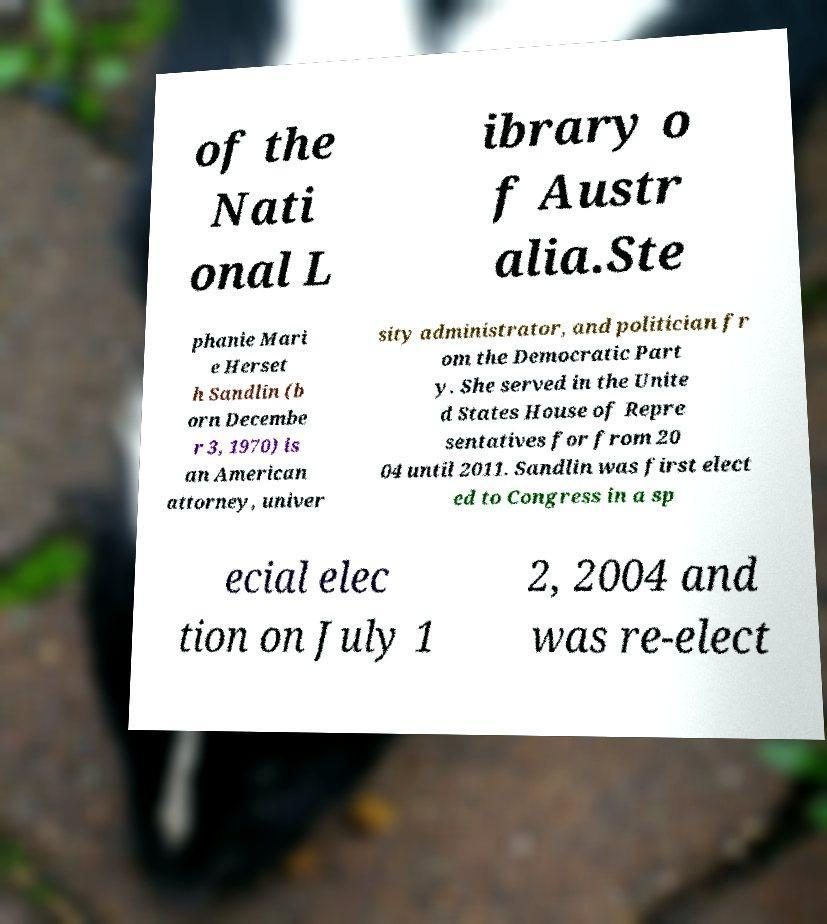Could you extract and type out the text from this image? of the Nati onal L ibrary o f Austr alia.Ste phanie Mari e Herset h Sandlin (b orn Decembe r 3, 1970) is an American attorney, univer sity administrator, and politician fr om the Democratic Part y. She served in the Unite d States House of Repre sentatives for from 20 04 until 2011. Sandlin was first elect ed to Congress in a sp ecial elec tion on July 1 2, 2004 and was re-elect 